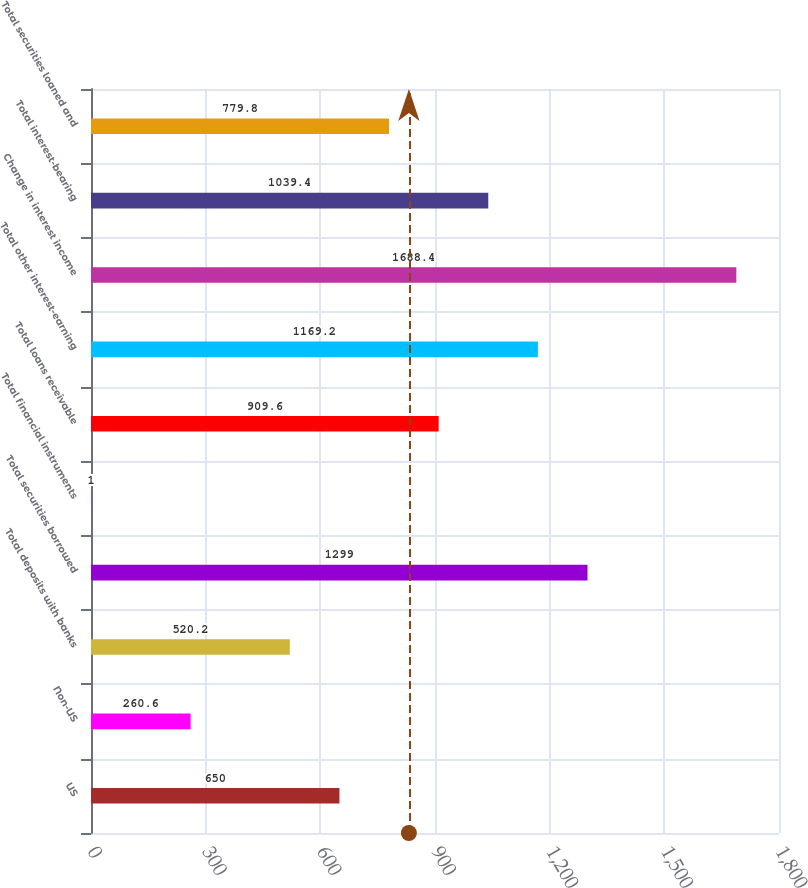Convert chart. <chart><loc_0><loc_0><loc_500><loc_500><bar_chart><fcel>US<fcel>Non-US<fcel>Total deposits with banks<fcel>Total securities borrowed<fcel>Total financial instruments<fcel>Total loans receivable<fcel>Total other interest-earning<fcel>Change in interest income<fcel>Total interest-bearing<fcel>Total securities loaned and<nl><fcel>650<fcel>260.6<fcel>520.2<fcel>1299<fcel>1<fcel>909.6<fcel>1169.2<fcel>1688.4<fcel>1039.4<fcel>779.8<nl></chart> 